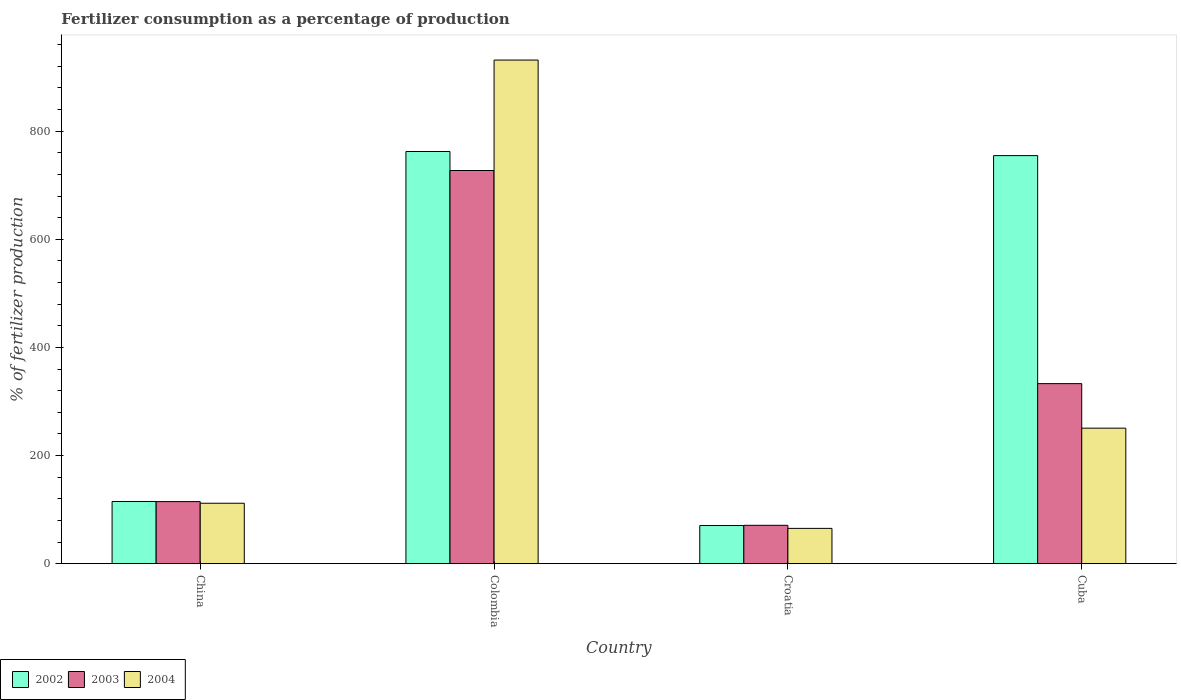How many different coloured bars are there?
Give a very brief answer. 3. Are the number of bars per tick equal to the number of legend labels?
Your response must be concise. Yes. Are the number of bars on each tick of the X-axis equal?
Your answer should be very brief. Yes. How many bars are there on the 4th tick from the left?
Ensure brevity in your answer.  3. What is the label of the 4th group of bars from the left?
Provide a short and direct response. Cuba. What is the percentage of fertilizers consumed in 2003 in China?
Make the answer very short. 114.92. Across all countries, what is the maximum percentage of fertilizers consumed in 2004?
Provide a short and direct response. 931.67. Across all countries, what is the minimum percentage of fertilizers consumed in 2003?
Your answer should be very brief. 71.05. In which country was the percentage of fertilizers consumed in 2004 minimum?
Make the answer very short. Croatia. What is the total percentage of fertilizers consumed in 2004 in the graph?
Give a very brief answer. 1359.7. What is the difference between the percentage of fertilizers consumed in 2002 in Croatia and that in Cuba?
Your answer should be very brief. -684.23. What is the difference between the percentage of fertilizers consumed in 2002 in Colombia and the percentage of fertilizers consumed in 2004 in China?
Offer a terse response. 650.62. What is the average percentage of fertilizers consumed in 2002 per country?
Your answer should be compact. 425.8. What is the difference between the percentage of fertilizers consumed of/in 2003 and percentage of fertilizers consumed of/in 2002 in China?
Provide a short and direct response. -0.21. What is the ratio of the percentage of fertilizers consumed in 2004 in China to that in Colombia?
Your answer should be compact. 0.12. Is the difference between the percentage of fertilizers consumed in 2003 in China and Croatia greater than the difference between the percentage of fertilizers consumed in 2002 in China and Croatia?
Ensure brevity in your answer.  No. What is the difference between the highest and the second highest percentage of fertilizers consumed in 2002?
Keep it short and to the point. -647.38. What is the difference between the highest and the lowest percentage of fertilizers consumed in 2002?
Provide a short and direct response. 691.83. In how many countries, is the percentage of fertilizers consumed in 2004 greater than the average percentage of fertilizers consumed in 2004 taken over all countries?
Give a very brief answer. 1. What does the 2nd bar from the right in Croatia represents?
Your answer should be compact. 2003. Is it the case that in every country, the sum of the percentage of fertilizers consumed in 2003 and percentage of fertilizers consumed in 2004 is greater than the percentage of fertilizers consumed in 2002?
Your answer should be compact. No. How many bars are there?
Offer a terse response. 12. Are all the bars in the graph horizontal?
Keep it short and to the point. No. Does the graph contain grids?
Provide a short and direct response. No. Where does the legend appear in the graph?
Ensure brevity in your answer.  Bottom left. What is the title of the graph?
Make the answer very short. Fertilizer consumption as a percentage of production. What is the label or title of the Y-axis?
Your response must be concise. % of fertilizer production. What is the % of fertilizer production of 2002 in China?
Make the answer very short. 115.12. What is the % of fertilizer production of 2003 in China?
Ensure brevity in your answer.  114.92. What is the % of fertilizer production of 2004 in China?
Keep it short and to the point. 111.88. What is the % of fertilizer production of 2002 in Colombia?
Keep it short and to the point. 762.5. What is the % of fertilizer production in 2003 in Colombia?
Your answer should be compact. 727.37. What is the % of fertilizer production in 2004 in Colombia?
Your answer should be compact. 931.67. What is the % of fertilizer production in 2002 in Croatia?
Give a very brief answer. 70.67. What is the % of fertilizer production in 2003 in Croatia?
Your response must be concise. 71.05. What is the % of fertilizer production of 2004 in Croatia?
Your answer should be very brief. 65.37. What is the % of fertilizer production in 2002 in Cuba?
Ensure brevity in your answer.  754.9. What is the % of fertilizer production of 2003 in Cuba?
Offer a terse response. 333.13. What is the % of fertilizer production of 2004 in Cuba?
Offer a terse response. 250.78. Across all countries, what is the maximum % of fertilizer production in 2002?
Give a very brief answer. 762.5. Across all countries, what is the maximum % of fertilizer production of 2003?
Provide a short and direct response. 727.37. Across all countries, what is the maximum % of fertilizer production in 2004?
Keep it short and to the point. 931.67. Across all countries, what is the minimum % of fertilizer production of 2002?
Your answer should be very brief. 70.67. Across all countries, what is the minimum % of fertilizer production of 2003?
Keep it short and to the point. 71.05. Across all countries, what is the minimum % of fertilizer production of 2004?
Your response must be concise. 65.37. What is the total % of fertilizer production in 2002 in the graph?
Provide a succinct answer. 1703.2. What is the total % of fertilizer production of 2003 in the graph?
Offer a terse response. 1246.46. What is the total % of fertilizer production in 2004 in the graph?
Offer a very short reply. 1359.7. What is the difference between the % of fertilizer production in 2002 in China and that in Colombia?
Ensure brevity in your answer.  -647.38. What is the difference between the % of fertilizer production of 2003 in China and that in Colombia?
Provide a short and direct response. -612.45. What is the difference between the % of fertilizer production in 2004 in China and that in Colombia?
Your answer should be compact. -819.79. What is the difference between the % of fertilizer production of 2002 in China and that in Croatia?
Keep it short and to the point. 44.45. What is the difference between the % of fertilizer production in 2003 in China and that in Croatia?
Your response must be concise. 43.87. What is the difference between the % of fertilizer production of 2004 in China and that in Croatia?
Ensure brevity in your answer.  46.51. What is the difference between the % of fertilizer production in 2002 in China and that in Cuba?
Your answer should be compact. -639.78. What is the difference between the % of fertilizer production of 2003 in China and that in Cuba?
Your answer should be very brief. -218.21. What is the difference between the % of fertilizer production of 2004 in China and that in Cuba?
Your answer should be compact. -138.9. What is the difference between the % of fertilizer production in 2002 in Colombia and that in Croatia?
Make the answer very short. 691.83. What is the difference between the % of fertilizer production in 2003 in Colombia and that in Croatia?
Provide a short and direct response. 656.32. What is the difference between the % of fertilizer production of 2004 in Colombia and that in Croatia?
Your answer should be compact. 866.29. What is the difference between the % of fertilizer production of 2002 in Colombia and that in Cuba?
Offer a terse response. 7.6. What is the difference between the % of fertilizer production in 2003 in Colombia and that in Cuba?
Your answer should be compact. 394.24. What is the difference between the % of fertilizer production of 2004 in Colombia and that in Cuba?
Provide a succinct answer. 680.89. What is the difference between the % of fertilizer production of 2002 in Croatia and that in Cuba?
Offer a very short reply. -684.23. What is the difference between the % of fertilizer production in 2003 in Croatia and that in Cuba?
Provide a short and direct response. -262.08. What is the difference between the % of fertilizer production of 2004 in Croatia and that in Cuba?
Offer a terse response. -185.4. What is the difference between the % of fertilizer production in 2002 in China and the % of fertilizer production in 2003 in Colombia?
Provide a short and direct response. -612.25. What is the difference between the % of fertilizer production of 2002 in China and the % of fertilizer production of 2004 in Colombia?
Ensure brevity in your answer.  -816.54. What is the difference between the % of fertilizer production of 2003 in China and the % of fertilizer production of 2004 in Colombia?
Provide a short and direct response. -816.75. What is the difference between the % of fertilizer production of 2002 in China and the % of fertilizer production of 2003 in Croatia?
Give a very brief answer. 44.07. What is the difference between the % of fertilizer production in 2002 in China and the % of fertilizer production in 2004 in Croatia?
Provide a succinct answer. 49.75. What is the difference between the % of fertilizer production in 2003 in China and the % of fertilizer production in 2004 in Croatia?
Your response must be concise. 49.54. What is the difference between the % of fertilizer production of 2002 in China and the % of fertilizer production of 2003 in Cuba?
Provide a succinct answer. -218. What is the difference between the % of fertilizer production of 2002 in China and the % of fertilizer production of 2004 in Cuba?
Your answer should be compact. -135.66. What is the difference between the % of fertilizer production in 2003 in China and the % of fertilizer production in 2004 in Cuba?
Provide a succinct answer. -135.86. What is the difference between the % of fertilizer production in 2002 in Colombia and the % of fertilizer production in 2003 in Croatia?
Give a very brief answer. 691.46. What is the difference between the % of fertilizer production of 2002 in Colombia and the % of fertilizer production of 2004 in Croatia?
Make the answer very short. 697.13. What is the difference between the % of fertilizer production in 2003 in Colombia and the % of fertilizer production in 2004 in Croatia?
Offer a very short reply. 661.99. What is the difference between the % of fertilizer production of 2002 in Colombia and the % of fertilizer production of 2003 in Cuba?
Your response must be concise. 429.38. What is the difference between the % of fertilizer production in 2002 in Colombia and the % of fertilizer production in 2004 in Cuba?
Your answer should be very brief. 511.73. What is the difference between the % of fertilizer production of 2003 in Colombia and the % of fertilizer production of 2004 in Cuba?
Your answer should be very brief. 476.59. What is the difference between the % of fertilizer production in 2002 in Croatia and the % of fertilizer production in 2003 in Cuba?
Provide a short and direct response. -262.45. What is the difference between the % of fertilizer production in 2002 in Croatia and the % of fertilizer production in 2004 in Cuba?
Give a very brief answer. -180.11. What is the difference between the % of fertilizer production of 2003 in Croatia and the % of fertilizer production of 2004 in Cuba?
Your answer should be compact. -179.73. What is the average % of fertilizer production in 2002 per country?
Give a very brief answer. 425.8. What is the average % of fertilizer production in 2003 per country?
Make the answer very short. 311.61. What is the average % of fertilizer production in 2004 per country?
Your answer should be compact. 339.93. What is the difference between the % of fertilizer production in 2002 and % of fertilizer production in 2003 in China?
Keep it short and to the point. 0.21. What is the difference between the % of fertilizer production in 2002 and % of fertilizer production in 2004 in China?
Ensure brevity in your answer.  3.24. What is the difference between the % of fertilizer production in 2003 and % of fertilizer production in 2004 in China?
Provide a succinct answer. 3.03. What is the difference between the % of fertilizer production in 2002 and % of fertilizer production in 2003 in Colombia?
Your response must be concise. 35.14. What is the difference between the % of fertilizer production of 2002 and % of fertilizer production of 2004 in Colombia?
Provide a short and direct response. -169.16. What is the difference between the % of fertilizer production in 2003 and % of fertilizer production in 2004 in Colombia?
Give a very brief answer. -204.3. What is the difference between the % of fertilizer production of 2002 and % of fertilizer production of 2003 in Croatia?
Ensure brevity in your answer.  -0.38. What is the difference between the % of fertilizer production in 2002 and % of fertilizer production in 2004 in Croatia?
Your answer should be compact. 5.3. What is the difference between the % of fertilizer production in 2003 and % of fertilizer production in 2004 in Croatia?
Ensure brevity in your answer.  5.67. What is the difference between the % of fertilizer production of 2002 and % of fertilizer production of 2003 in Cuba?
Ensure brevity in your answer.  421.78. What is the difference between the % of fertilizer production of 2002 and % of fertilizer production of 2004 in Cuba?
Your answer should be very brief. 504.12. What is the difference between the % of fertilizer production in 2003 and % of fertilizer production in 2004 in Cuba?
Provide a succinct answer. 82.35. What is the ratio of the % of fertilizer production in 2002 in China to that in Colombia?
Your response must be concise. 0.15. What is the ratio of the % of fertilizer production of 2003 in China to that in Colombia?
Give a very brief answer. 0.16. What is the ratio of the % of fertilizer production of 2004 in China to that in Colombia?
Give a very brief answer. 0.12. What is the ratio of the % of fertilizer production of 2002 in China to that in Croatia?
Keep it short and to the point. 1.63. What is the ratio of the % of fertilizer production in 2003 in China to that in Croatia?
Make the answer very short. 1.62. What is the ratio of the % of fertilizer production in 2004 in China to that in Croatia?
Offer a terse response. 1.71. What is the ratio of the % of fertilizer production of 2002 in China to that in Cuba?
Your answer should be compact. 0.15. What is the ratio of the % of fertilizer production in 2003 in China to that in Cuba?
Offer a very short reply. 0.34. What is the ratio of the % of fertilizer production of 2004 in China to that in Cuba?
Your response must be concise. 0.45. What is the ratio of the % of fertilizer production in 2002 in Colombia to that in Croatia?
Ensure brevity in your answer.  10.79. What is the ratio of the % of fertilizer production in 2003 in Colombia to that in Croatia?
Provide a succinct answer. 10.24. What is the ratio of the % of fertilizer production in 2004 in Colombia to that in Croatia?
Ensure brevity in your answer.  14.25. What is the ratio of the % of fertilizer production of 2003 in Colombia to that in Cuba?
Keep it short and to the point. 2.18. What is the ratio of the % of fertilizer production of 2004 in Colombia to that in Cuba?
Provide a short and direct response. 3.72. What is the ratio of the % of fertilizer production in 2002 in Croatia to that in Cuba?
Provide a succinct answer. 0.09. What is the ratio of the % of fertilizer production in 2003 in Croatia to that in Cuba?
Your answer should be compact. 0.21. What is the ratio of the % of fertilizer production in 2004 in Croatia to that in Cuba?
Give a very brief answer. 0.26. What is the difference between the highest and the second highest % of fertilizer production in 2002?
Give a very brief answer. 7.6. What is the difference between the highest and the second highest % of fertilizer production of 2003?
Offer a terse response. 394.24. What is the difference between the highest and the second highest % of fertilizer production of 2004?
Your answer should be very brief. 680.89. What is the difference between the highest and the lowest % of fertilizer production in 2002?
Offer a very short reply. 691.83. What is the difference between the highest and the lowest % of fertilizer production in 2003?
Ensure brevity in your answer.  656.32. What is the difference between the highest and the lowest % of fertilizer production of 2004?
Provide a succinct answer. 866.29. 